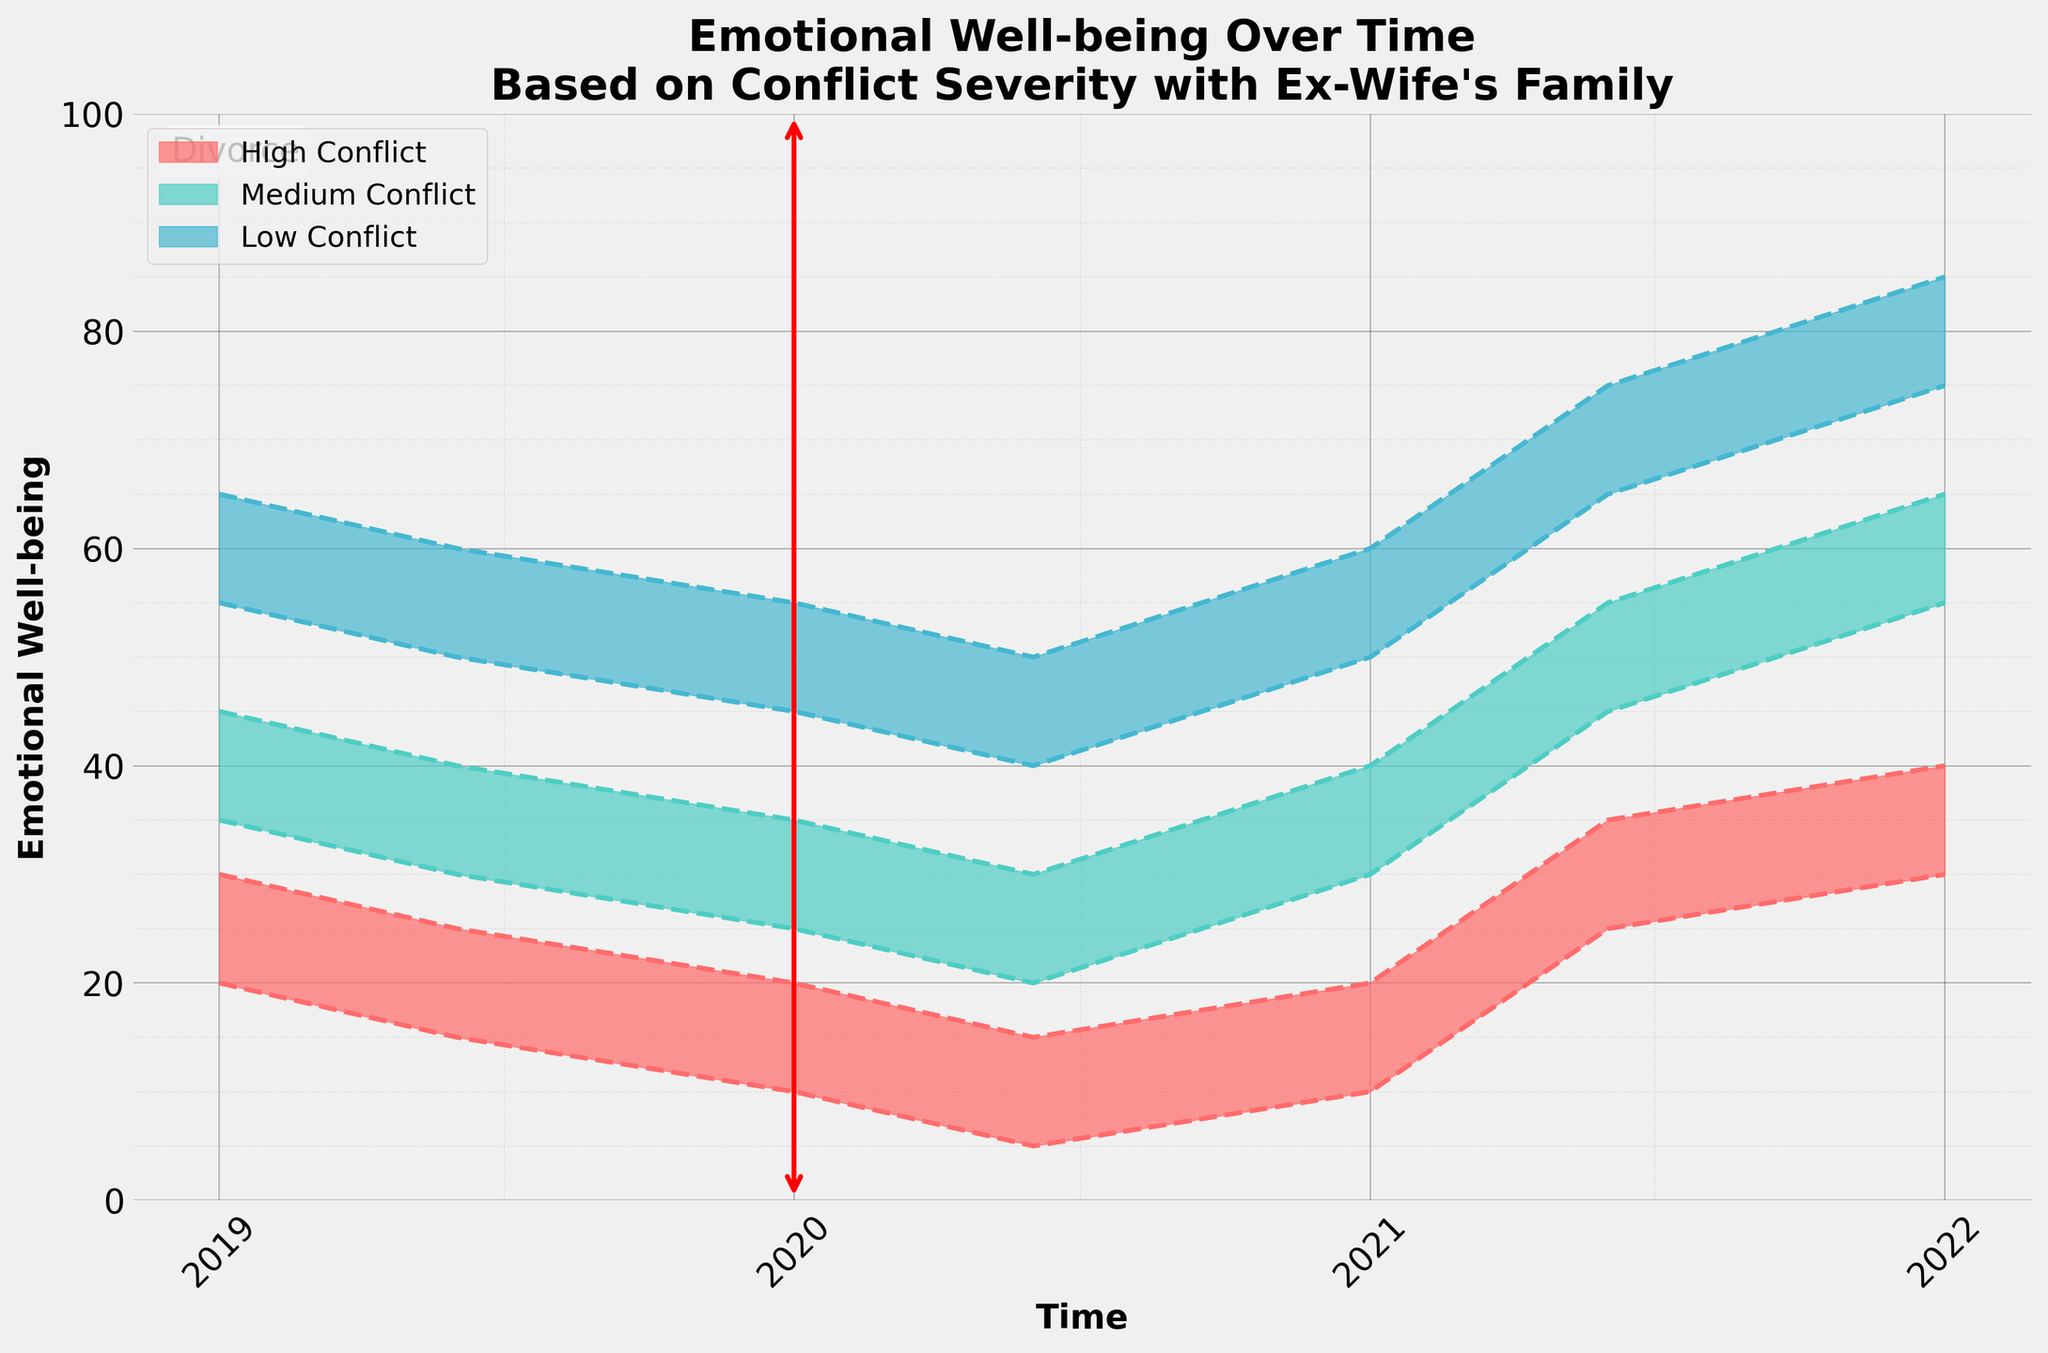What is the title of the chart? The title of the chart is located at the top and generally describes the content or purpose of the chart. It reads "Emotional Well-being Over Time Based on Conflict Severity with Ex-Wife's Family."
Answer: Emotional Well-being Over Time Based on Conflict Severity with Ex-Wife's Family Which group experienced the lowest emotional well-being at the lowest point in time? To determine this, look at the minimum well-being values in the chart. The lowest point (5) occurs in the High Conflict group around mid-2020.
Answer: High Conflict How did the emotional well-being of the Low Conflict group change from the beginning to the end of the period shown? Review the well-being range for the Low Conflict group at both the start and end of the timeline. At the start, it is 55-65, and at the end, it is 75-85. The range increased significantly.
Answer: Increased Which conflict severity group shows the most considerable improvement in emotional well-being after the divorce? Compare the well-being ranges post-divorce. The High Conflict group's range grew from 5-15 to 30-40, indicating the most significant improvement.
Answer: High Conflict During which period does the Medium Conflict group's well-being score fall between 20 and 30? By observing the well-being ranges in the different time periods, the Medium Conflict group's well-being scores fall between 20 and 30 during mid-2020.
Answer: Mid-2020 Does the High Conflict group's emotional well-being ever surpass the Low Conflict group's well-being? By examining the well-being ranges of both groups across the timeline, it is evident that the well-being of the High Conflict group never surpasses the Low Conflict group.
Answer: No What is the range of emotional well-being for the Medium Conflict group in 2021-06-01? Look for the specified date and the well-being range associated with it. For the Medium Conflict group in mid-2021, the range is 45-55.
Answer: 45-55 Are there any periods where the emotional well-being of the High Conflict and Medium Conflict groups overlap? Find periods where the ranges for High Conflict and Medium Conflict intersect. They overlap around early to mid-2019 with ranges of 20-30 for High Conflict and 25-35 for Medium Conflict.
Answer: Early to mid-2019 When did the High Conflict group's emotional well-being first show a noticeable improvement after the divorce? Identify post-divorce periods and notice the upward shift in well-being for the High Conflict group, which first improves significantly in mid-2021.
Answer: Mid-2021 